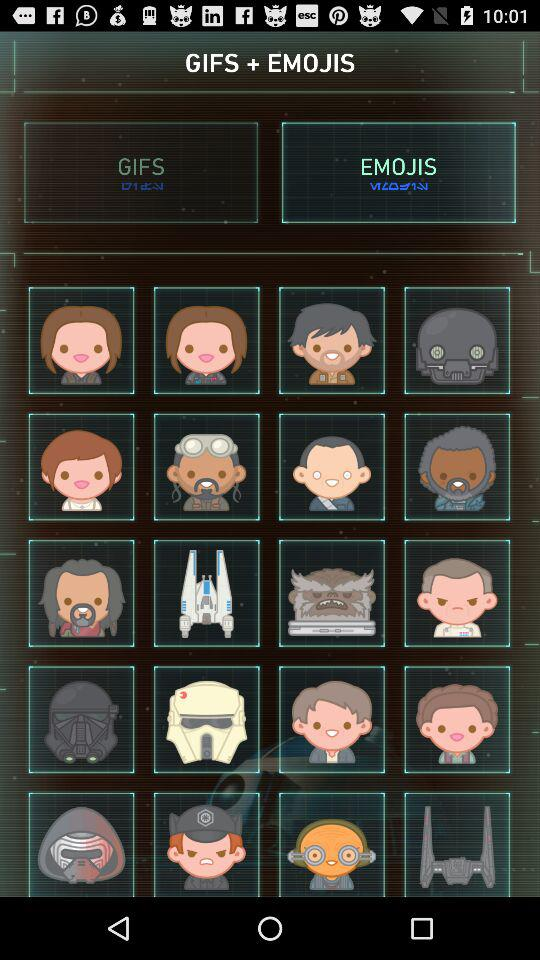Which tab is selected? The selected tab is "EMOJIS". 